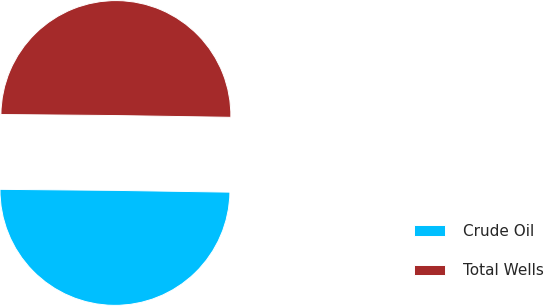Convert chart to OTSL. <chart><loc_0><loc_0><loc_500><loc_500><pie_chart><fcel>Crude Oil<fcel>Total Wells<nl><fcel>49.9%<fcel>50.1%<nl></chart> 